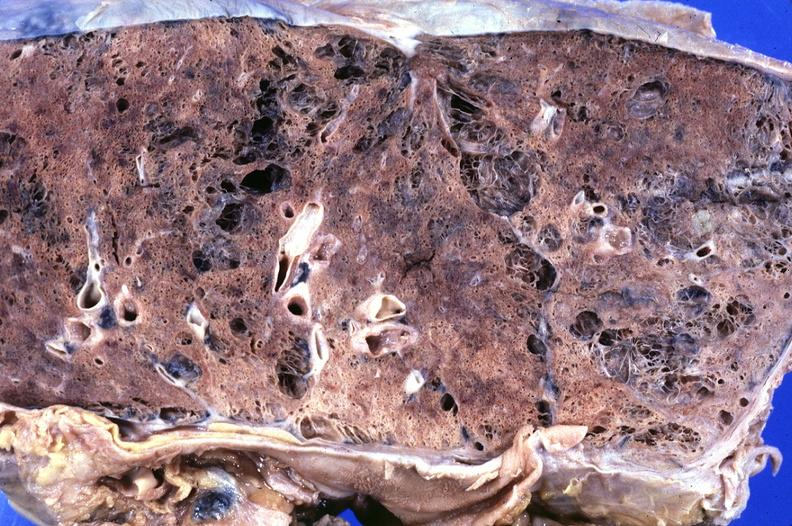what is present?
Answer the question using a single word or phrase. Respiratory 